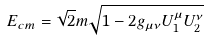<formula> <loc_0><loc_0><loc_500><loc_500>E _ { c m } = \sqrt { 2 } m \sqrt { 1 - 2 g _ { \mu \nu } U _ { 1 } ^ { \mu } U _ { 2 } ^ { \nu } }</formula> 